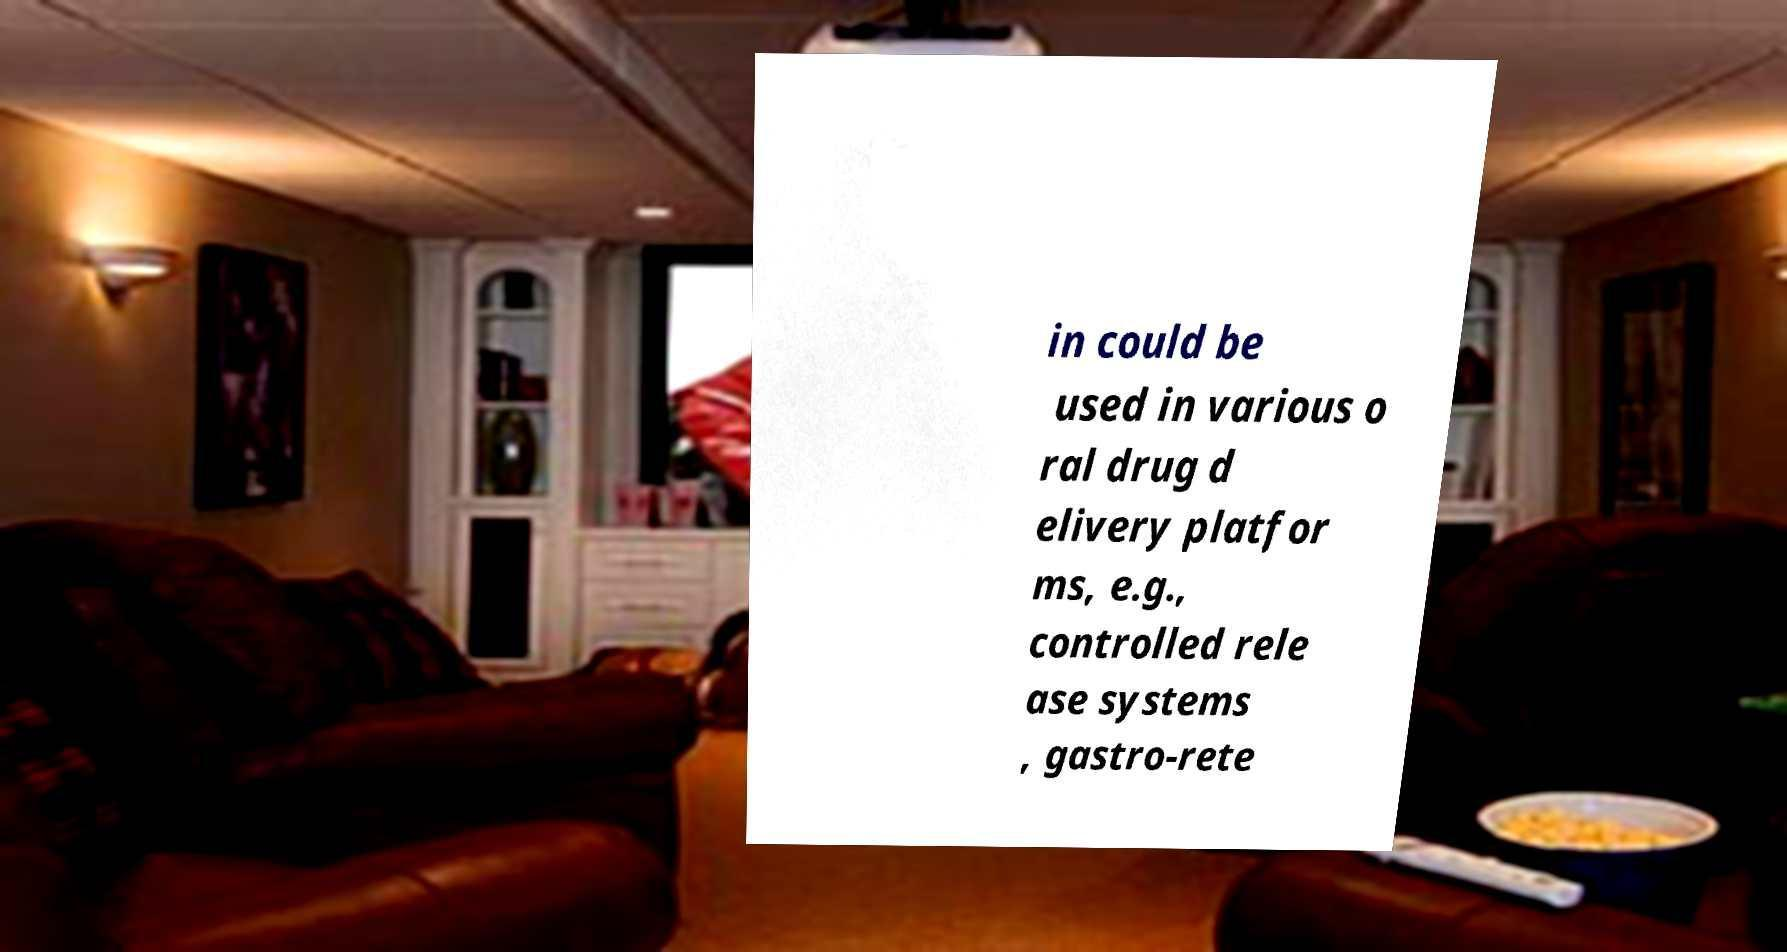Can you read and provide the text displayed in the image?This photo seems to have some interesting text. Can you extract and type it out for me? in could be used in various o ral drug d elivery platfor ms, e.g., controlled rele ase systems , gastro-rete 